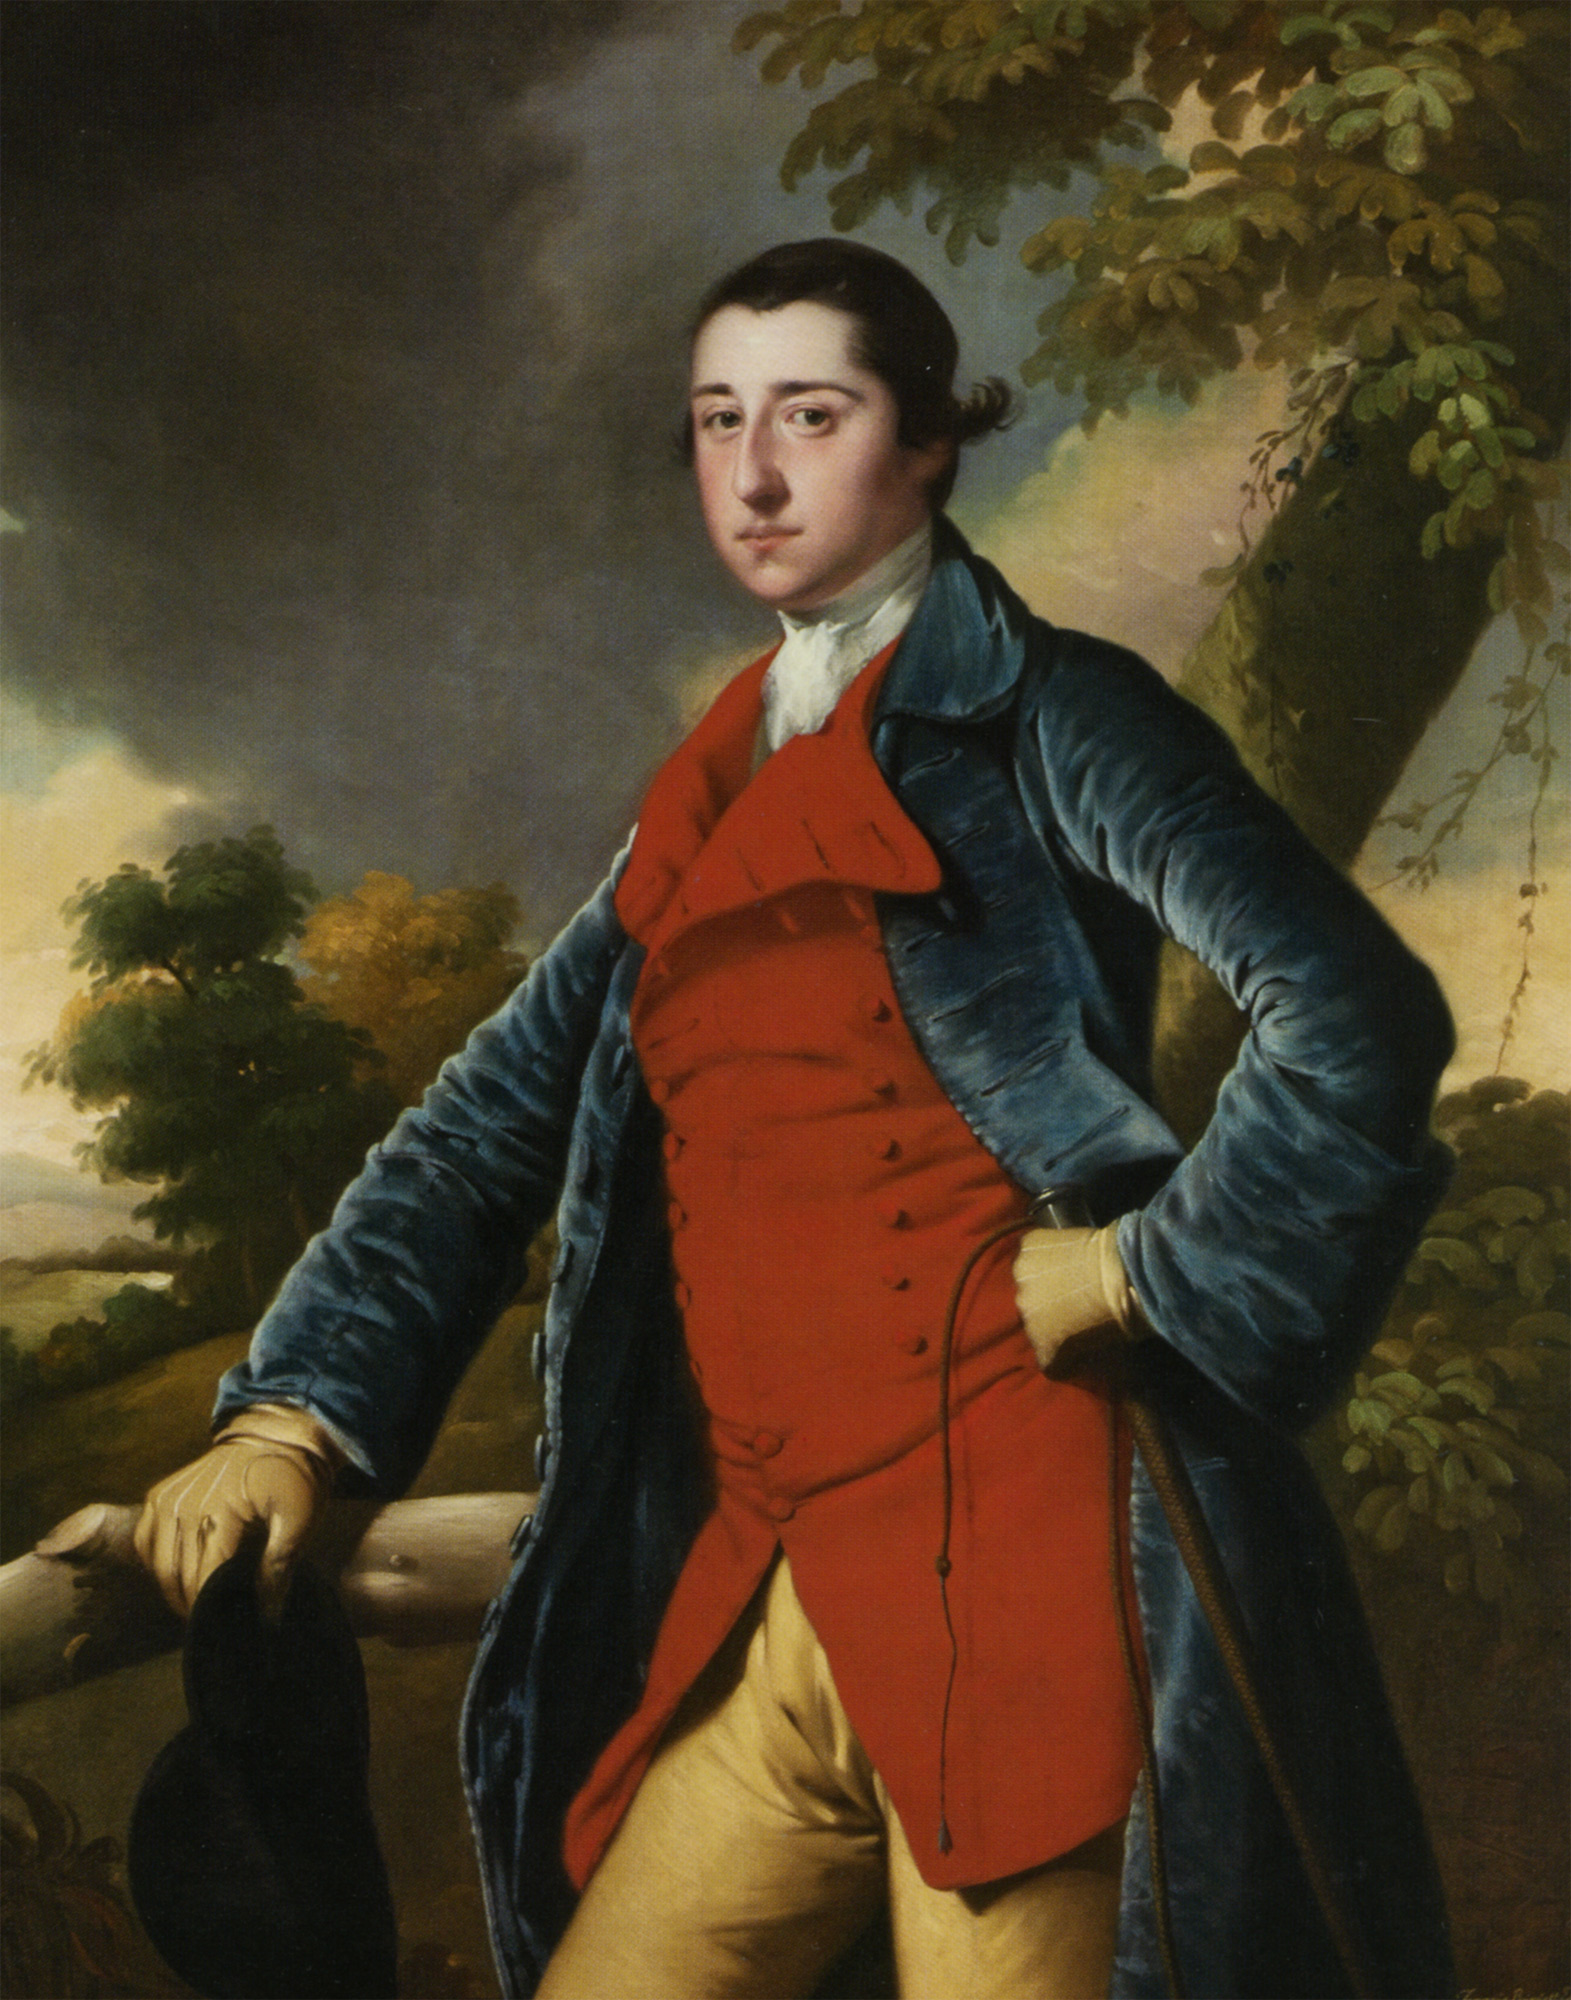Create a fictional story involving this man within the landscape. As the sun began to set, casting long shadows over the rolling hills, Sir Edmund Chartwell stood pensively by the old oak tree, his blue coat and red waistcoat gleaming in the golden light. In his hand, he clutched a letter from his beloved, Lady Isabella. She had written of a mysterious artifact, said to grant immense wisdom, hidden somewhere in the expansive forest behind him. Driven by curiosity and love, Sir Edmund set out on a quest to uncover this relic, facing unforeseen challenges and uncovering secrets of his lineage along the way. 